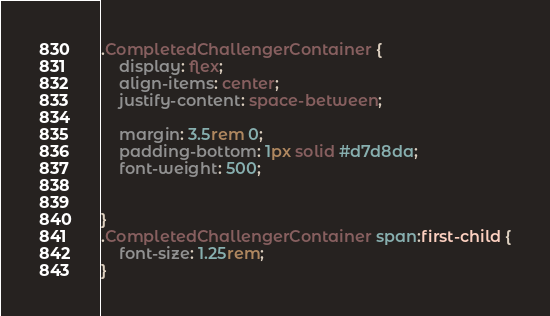Convert code to text. <code><loc_0><loc_0><loc_500><loc_500><_CSS_>.CompletedChallengerContainer {
    display: flex;
    align-items: center;
    justify-content: space-between;

    margin: 3.5rem 0;
    padding-bottom: 1px solid #d7d8da;
    font-weight: 500;


}
.CompletedChallengerContainer span:first-child {
    font-size: 1.25rem;
}</code> 